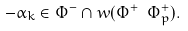<formula> <loc_0><loc_0><loc_500><loc_500>- \alpha _ { k } \in \Phi ^ { - } \cap w ( \Phi ^ { + } \ \Phi _ { p } ^ { + } ) .</formula> 